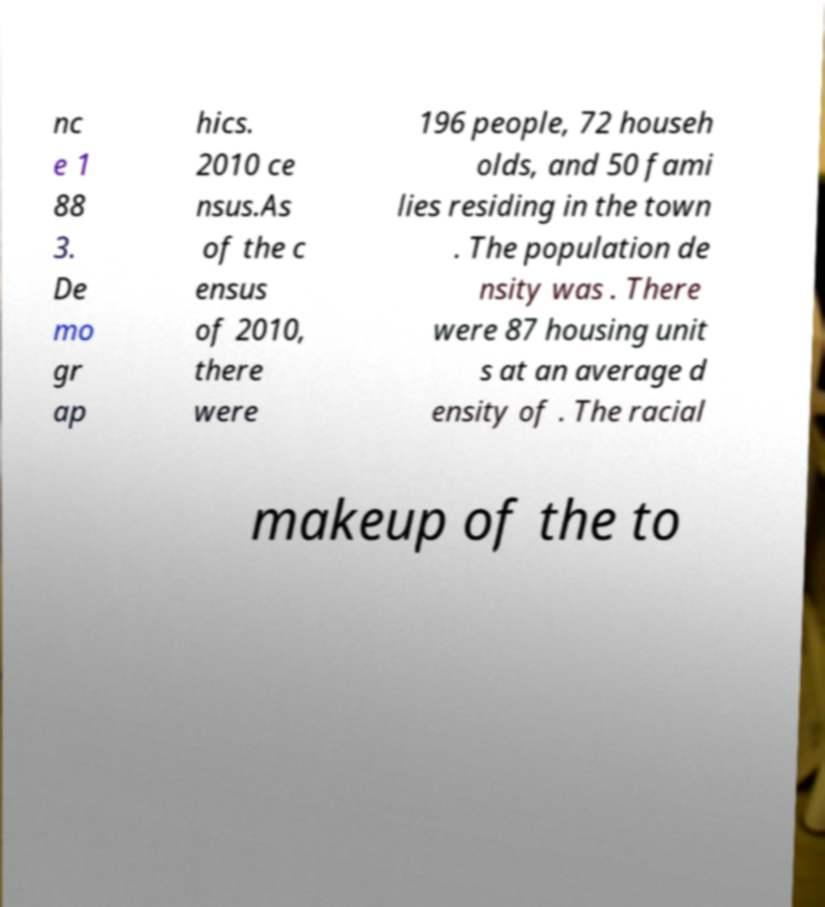Can you read and provide the text displayed in the image?This photo seems to have some interesting text. Can you extract and type it out for me? nc e 1 88 3. De mo gr ap hics. 2010 ce nsus.As of the c ensus of 2010, there were 196 people, 72 househ olds, and 50 fami lies residing in the town . The population de nsity was . There were 87 housing unit s at an average d ensity of . The racial makeup of the to 